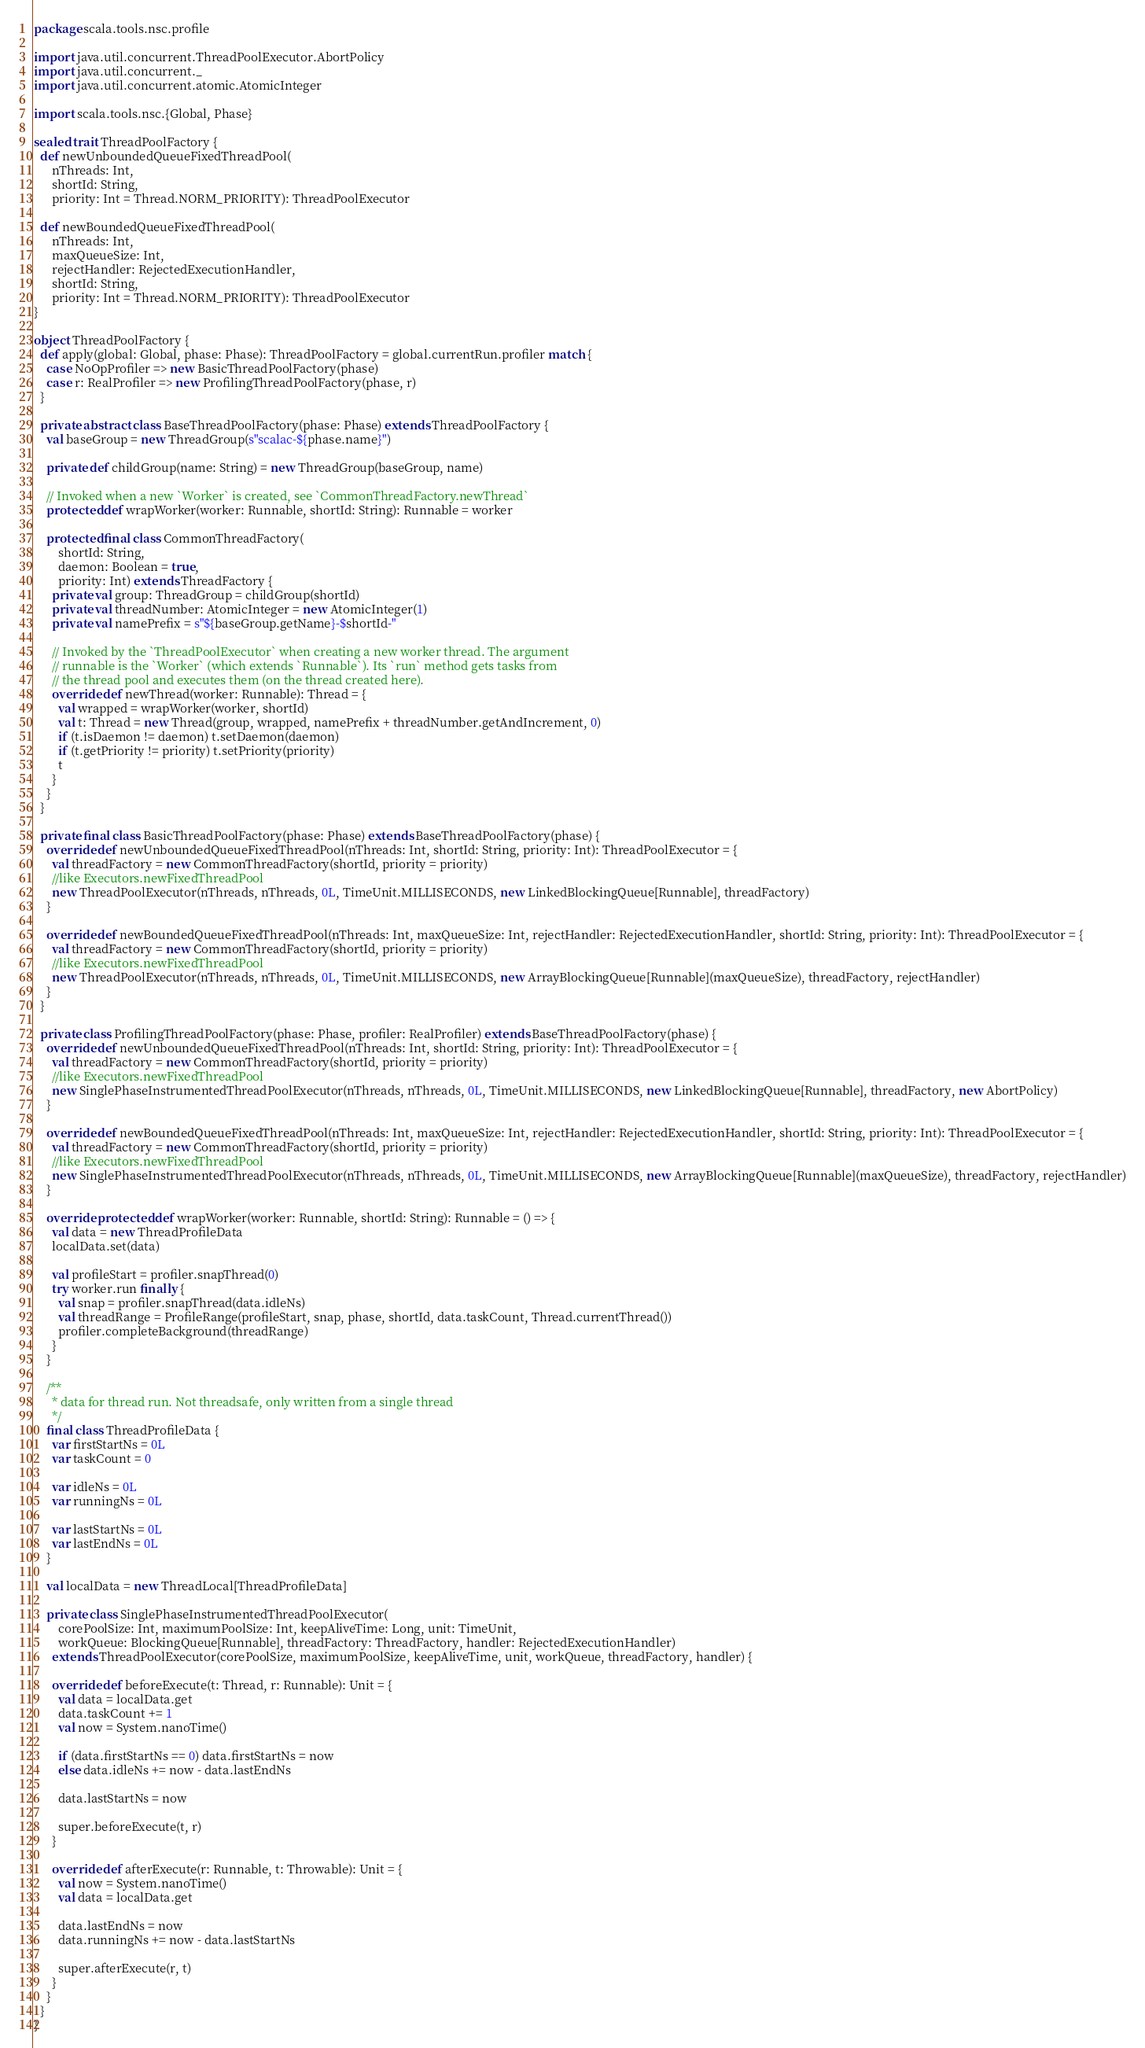<code> <loc_0><loc_0><loc_500><loc_500><_Scala_>package scala.tools.nsc.profile

import java.util.concurrent.ThreadPoolExecutor.AbortPolicy
import java.util.concurrent._
import java.util.concurrent.atomic.AtomicInteger

import scala.tools.nsc.{Global, Phase}

sealed trait ThreadPoolFactory {
  def newUnboundedQueueFixedThreadPool(
      nThreads: Int,
      shortId: String,
      priority: Int = Thread.NORM_PRIORITY): ThreadPoolExecutor

  def newBoundedQueueFixedThreadPool(
      nThreads: Int,
      maxQueueSize: Int,
      rejectHandler: RejectedExecutionHandler,
      shortId: String,
      priority: Int = Thread.NORM_PRIORITY): ThreadPoolExecutor
}

object ThreadPoolFactory {
  def apply(global: Global, phase: Phase): ThreadPoolFactory = global.currentRun.profiler match {
    case NoOpProfiler => new BasicThreadPoolFactory(phase)
    case r: RealProfiler => new ProfilingThreadPoolFactory(phase, r)
  }

  private abstract class BaseThreadPoolFactory(phase: Phase) extends ThreadPoolFactory {
    val baseGroup = new ThreadGroup(s"scalac-${phase.name}")

    private def childGroup(name: String) = new ThreadGroup(baseGroup, name)

    // Invoked when a new `Worker` is created, see `CommonThreadFactory.newThread`
    protected def wrapWorker(worker: Runnable, shortId: String): Runnable = worker

    protected final class CommonThreadFactory(
        shortId: String,
        daemon: Boolean = true,
        priority: Int) extends ThreadFactory {
      private val group: ThreadGroup = childGroup(shortId)
      private val threadNumber: AtomicInteger = new AtomicInteger(1)
      private val namePrefix = s"${baseGroup.getName}-$shortId-"

      // Invoked by the `ThreadPoolExecutor` when creating a new worker thread. The argument
      // runnable is the `Worker` (which extends `Runnable`). Its `run` method gets tasks from
      // the thread pool and executes them (on the thread created here).
      override def newThread(worker: Runnable): Thread = {
        val wrapped = wrapWorker(worker, shortId)
        val t: Thread = new Thread(group, wrapped, namePrefix + threadNumber.getAndIncrement, 0)
        if (t.isDaemon != daemon) t.setDaemon(daemon)
        if (t.getPriority != priority) t.setPriority(priority)
        t
      }
    }
  }

  private final class BasicThreadPoolFactory(phase: Phase) extends BaseThreadPoolFactory(phase) {
    override def newUnboundedQueueFixedThreadPool(nThreads: Int, shortId: String, priority: Int): ThreadPoolExecutor = {
      val threadFactory = new CommonThreadFactory(shortId, priority = priority)
      //like Executors.newFixedThreadPool
      new ThreadPoolExecutor(nThreads, nThreads, 0L, TimeUnit.MILLISECONDS, new LinkedBlockingQueue[Runnable], threadFactory)
    }

    override def newBoundedQueueFixedThreadPool(nThreads: Int, maxQueueSize: Int, rejectHandler: RejectedExecutionHandler, shortId: String, priority: Int): ThreadPoolExecutor = {
      val threadFactory = new CommonThreadFactory(shortId, priority = priority)
      //like Executors.newFixedThreadPool
      new ThreadPoolExecutor(nThreads, nThreads, 0L, TimeUnit.MILLISECONDS, new ArrayBlockingQueue[Runnable](maxQueueSize), threadFactory, rejectHandler)
    }
  }

  private class ProfilingThreadPoolFactory(phase: Phase, profiler: RealProfiler) extends BaseThreadPoolFactory(phase) {
    override def newUnboundedQueueFixedThreadPool(nThreads: Int, shortId: String, priority: Int): ThreadPoolExecutor = {
      val threadFactory = new CommonThreadFactory(shortId, priority = priority)
      //like Executors.newFixedThreadPool
      new SinglePhaseInstrumentedThreadPoolExecutor(nThreads, nThreads, 0L, TimeUnit.MILLISECONDS, new LinkedBlockingQueue[Runnable], threadFactory, new AbortPolicy)
    }

    override def newBoundedQueueFixedThreadPool(nThreads: Int, maxQueueSize: Int, rejectHandler: RejectedExecutionHandler, shortId: String, priority: Int): ThreadPoolExecutor = {
      val threadFactory = new CommonThreadFactory(shortId, priority = priority)
      //like Executors.newFixedThreadPool
      new SinglePhaseInstrumentedThreadPoolExecutor(nThreads, nThreads, 0L, TimeUnit.MILLISECONDS, new ArrayBlockingQueue[Runnable](maxQueueSize), threadFactory, rejectHandler)
    }

    override protected def wrapWorker(worker: Runnable, shortId: String): Runnable = () => {
      val data = new ThreadProfileData
      localData.set(data)

      val profileStart = profiler.snapThread(0)
      try worker.run finally {
        val snap = profiler.snapThread(data.idleNs)
        val threadRange = ProfileRange(profileStart, snap, phase, shortId, data.taskCount, Thread.currentThread())
        profiler.completeBackground(threadRange)
      }
    }

    /**
      * data for thread run. Not threadsafe, only written from a single thread
      */
    final class ThreadProfileData {
      var firstStartNs = 0L
      var taskCount = 0

      var idleNs = 0L
      var runningNs = 0L

      var lastStartNs = 0L
      var lastEndNs = 0L
    }

    val localData = new ThreadLocal[ThreadProfileData]

    private class SinglePhaseInstrumentedThreadPoolExecutor(
        corePoolSize: Int, maximumPoolSize: Int, keepAliveTime: Long, unit: TimeUnit,
        workQueue: BlockingQueue[Runnable], threadFactory: ThreadFactory, handler: RejectedExecutionHandler)
      extends ThreadPoolExecutor(corePoolSize, maximumPoolSize, keepAliveTime, unit, workQueue, threadFactory, handler) {

      override def beforeExecute(t: Thread, r: Runnable): Unit = {
        val data = localData.get
        data.taskCount += 1
        val now = System.nanoTime()

        if (data.firstStartNs == 0) data.firstStartNs = now
        else data.idleNs += now - data.lastEndNs

        data.lastStartNs = now

        super.beforeExecute(t, r)
      }

      override def afterExecute(r: Runnable, t: Throwable): Unit = {
        val now = System.nanoTime()
        val data = localData.get

        data.lastEndNs = now
        data.runningNs += now - data.lastStartNs

        super.afterExecute(r, t)
      }
    }
  }
}</code> 